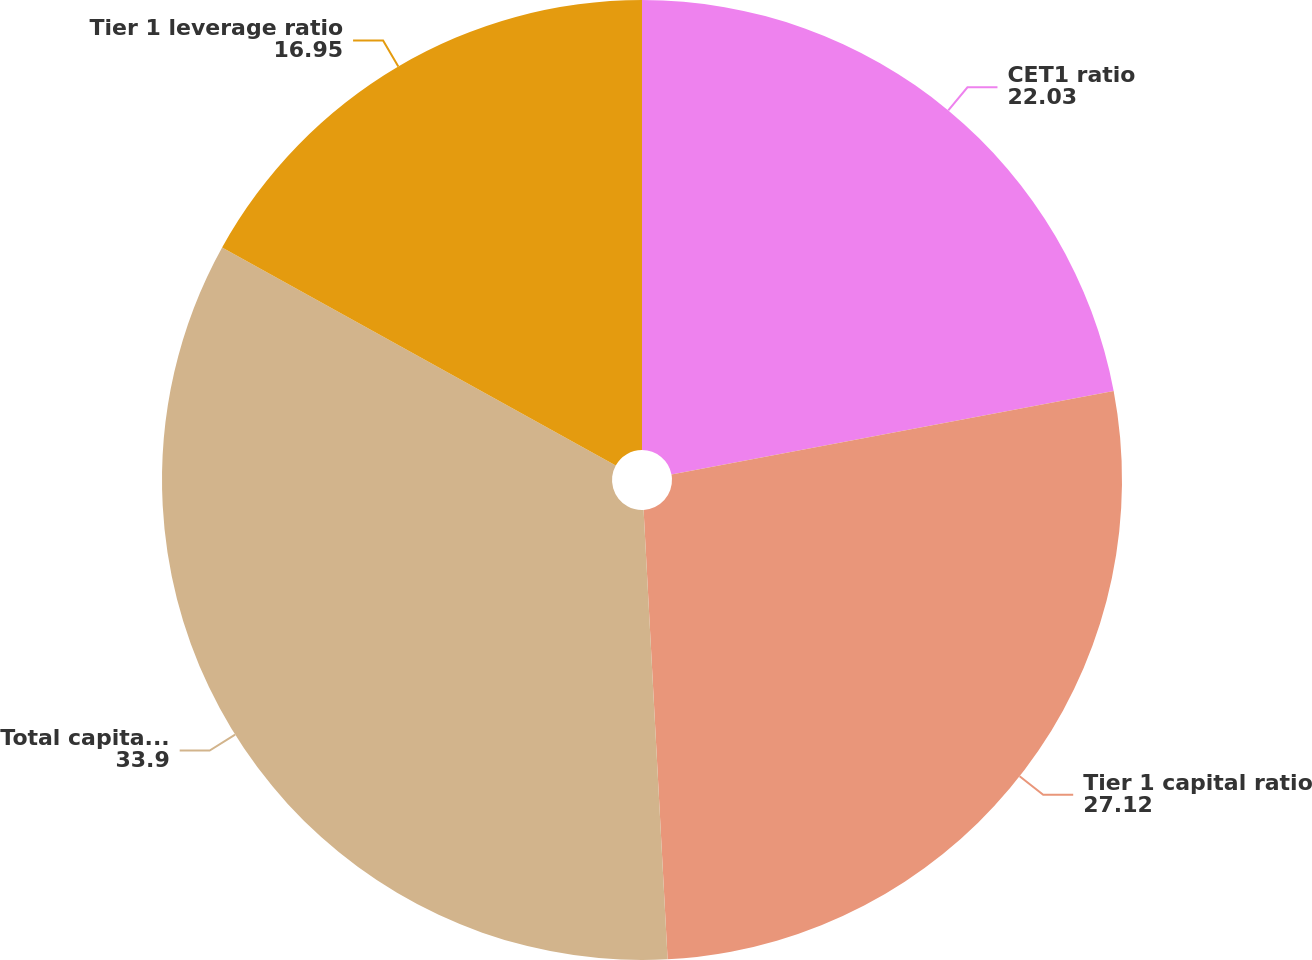<chart> <loc_0><loc_0><loc_500><loc_500><pie_chart><fcel>CET1 ratio<fcel>Tier 1 capital ratio<fcel>Total capital ratio<fcel>Tier 1 leverage ratio<nl><fcel>22.03%<fcel>27.12%<fcel>33.9%<fcel>16.95%<nl></chart> 